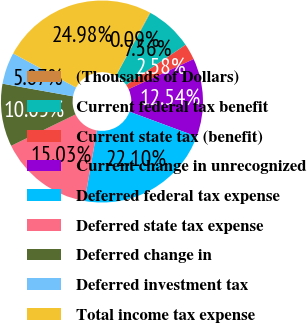Convert chart. <chart><loc_0><loc_0><loc_500><loc_500><pie_chart><fcel>(Thousands of Dollars)<fcel>Current federal tax benefit<fcel>Current state tax (benefit)<fcel>Current change in unrecognized<fcel>Deferred federal tax expense<fcel>Deferred state tax expense<fcel>Deferred change in<fcel>Deferred investment tax<fcel>Total income tax expense<nl><fcel>0.09%<fcel>7.56%<fcel>2.58%<fcel>12.54%<fcel>22.1%<fcel>15.03%<fcel>10.05%<fcel>5.07%<fcel>24.98%<nl></chart> 